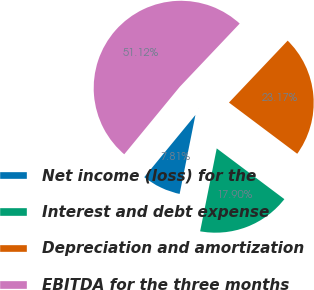Convert chart to OTSL. <chart><loc_0><loc_0><loc_500><loc_500><pie_chart><fcel>Net income (loss) for the<fcel>Interest and debt expense<fcel>Depreciation and amortization<fcel>EBITDA for the three months<nl><fcel>7.81%<fcel>17.9%<fcel>23.17%<fcel>51.12%<nl></chart> 